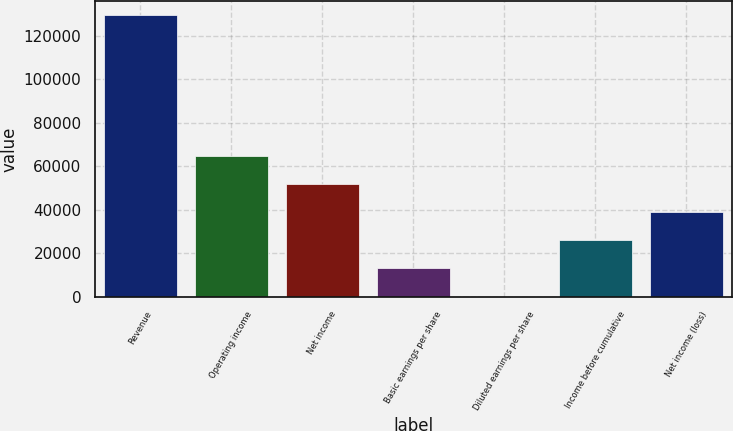<chart> <loc_0><loc_0><loc_500><loc_500><bar_chart><fcel>Revenue<fcel>Operating income<fcel>Net income<fcel>Basic earnings per share<fcel>Diluted earnings per share<fcel>Income before cumulative<fcel>Net income (loss)<nl><fcel>129461<fcel>64730.7<fcel>51784.6<fcel>12946.4<fcel>0.36<fcel>25892.5<fcel>38838.5<nl></chart> 